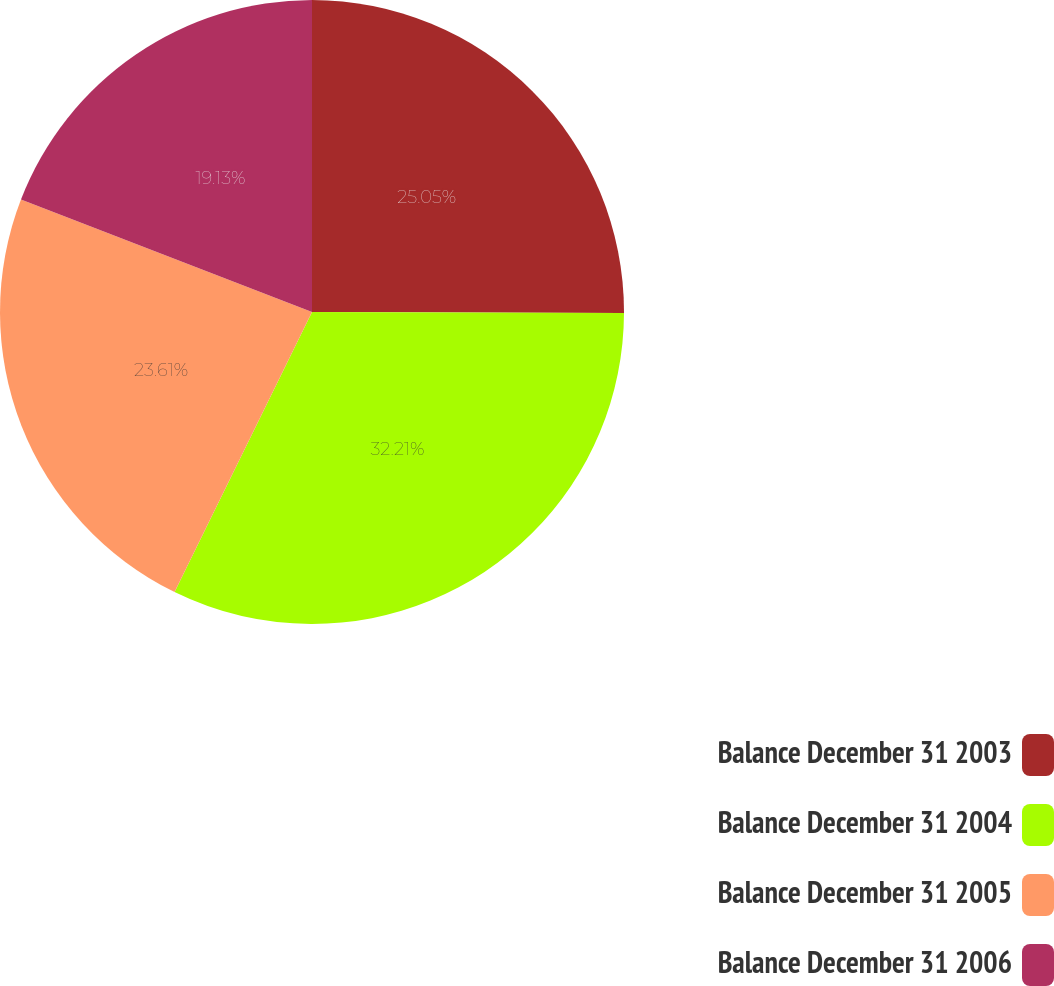Convert chart. <chart><loc_0><loc_0><loc_500><loc_500><pie_chart><fcel>Balance December 31 2003<fcel>Balance December 31 2004<fcel>Balance December 31 2005<fcel>Balance December 31 2006<nl><fcel>25.05%<fcel>32.21%<fcel>23.61%<fcel>19.13%<nl></chart> 